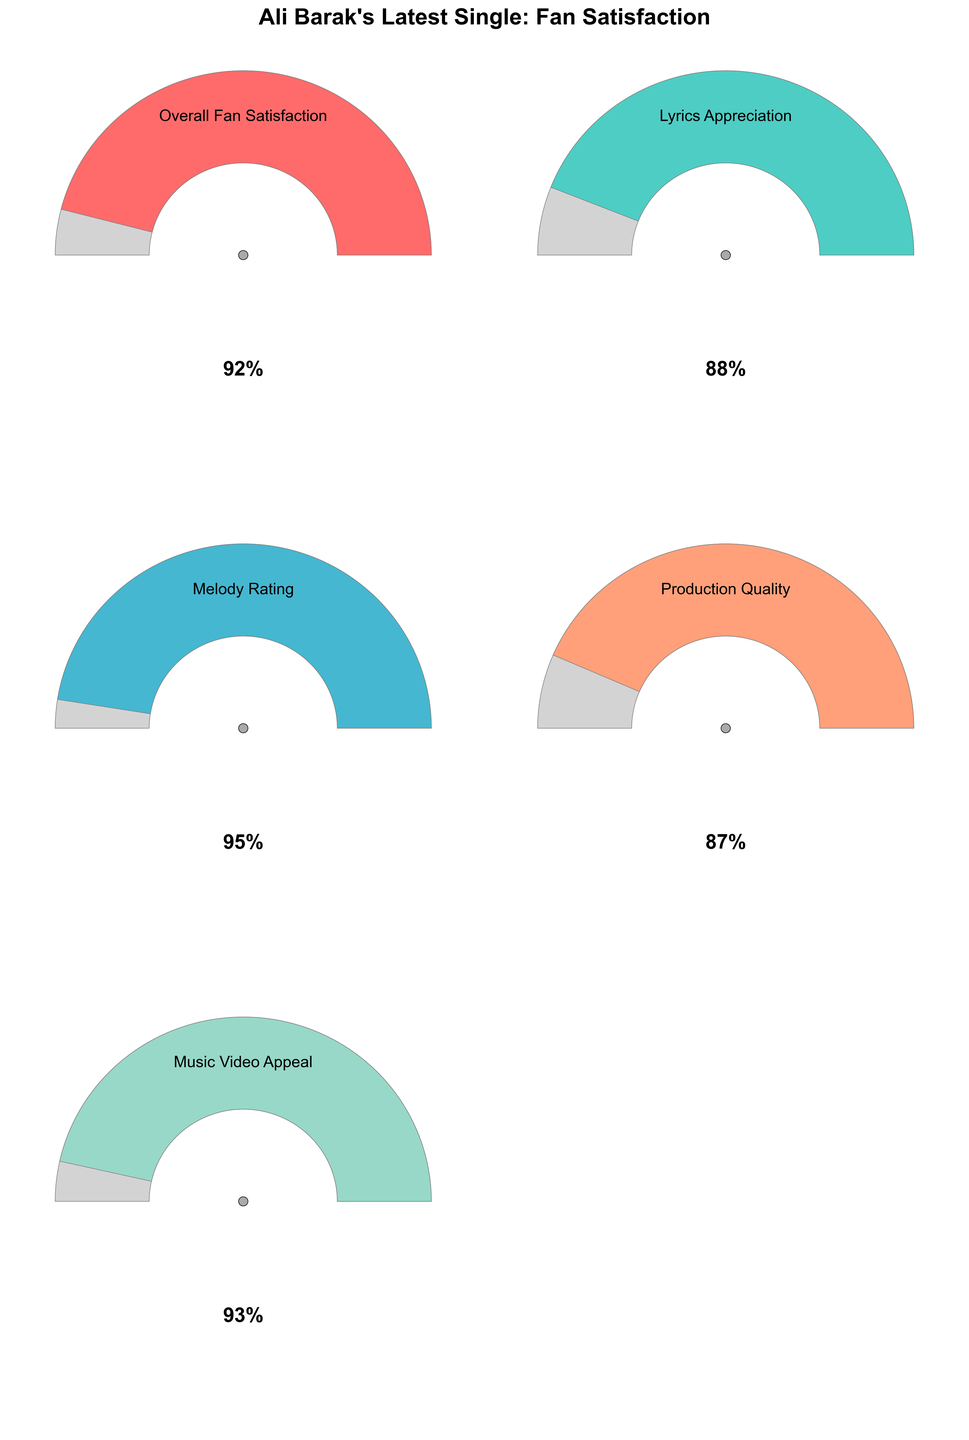What's the highest fan rating among all categories? The highest fan rating can be determined by looking at the gauge with the largest value. The values for each category are: Overall Fan Satisfaction 92%, Lyrics Appreciation 88%, Melody Rating 95%, Production Quality 87%, Music Video Appeal 93%. The highest value is 95%.
Answer: 95% Which category has the lowest rating? The lowest rating can be observed by checking the smallest value in the figure. The ratings are: Overall Fan Satisfaction 92%, Lyrics Appreciation 88%, Melody Rating 95%, Production Quality 87%, Music Video Appeal 93%. The smallest value is Production Quality with 87%.
Answer: Production Quality What's the title of the figure? The title of the figure is displayed prominently at the top. It reads, "Ali Barak's Latest Single: Fan Satisfaction".
Answer: Ali Barak's Latest Single: Fan Satisfaction How does the Lyrics Appreciation rating compare to the Production Quality rating? To compare these two ratings, we need to look at the value for Lyrics Appreciation and Production Quality. Lyrics Appreciation is 88% and Production Quality is 87%. Since 88% is greater than 87%, Lyrics Appreciation is higher.
Answer: Higher What is the average fan rating across all categories? To find the average, sum all the ratings and divide by the number of categories: (92 + 88 + 95 + 87 + 93) / 5 = 455 / 5 = 91%.
Answer: 91% Which aspect of Ali Barak's latest single has the most similar rating to the Overall Fan Satisfaction? The Overall Fan Satisfaction rating is 92%. Comparing this to the other ratings: Lyrics Appreciation 88%, Melody Rating 95%, Production Quality 87%, Music Video Appeal 93%. The Music Video Appeal is closest with a value of 93%.
Answer: Music Video Appeal How many categories have a rating above 90%? Count the number of categories with a rating greater than 90%. The values greater than 90% are: Overall Fan Satisfaction 92%, Melody Rating 95%, Music Video Appeal 93%. There are three categories.
Answer: 3 If the criteria for successful aspects are ratings above 85%, how many aspects meet this criterion? Count the number of categories with ratings greater than 85%. All values (92%, 88%, 95%, 87%, 93%) exceed 85%. Thus, all five categories meet the criterion.
Answer: 5 Can you rank the categories from highest to lowest rating? Arrange the categories by their ratings: Melody Rating 95%, Music Video Appeal 93%, Overall Fan Satisfaction 92%, Lyrics Appreciation 88%, Production Quality 87%.
Answer: Melody Rating, Music Video Appeal, Overall Fan Satisfaction, Lyrics Appreciation, Production Quality What percentage of categories have a rating of 90% or higher? Determine the percentage based on categories with a rating of 90% or higher (Overall Fan Satisfaction 92%, Melody Rating 95%, Music Video Appeal 93%). There are 3 out of 5 categories, so (3/5) * 100 = 60%.
Answer: 60% 